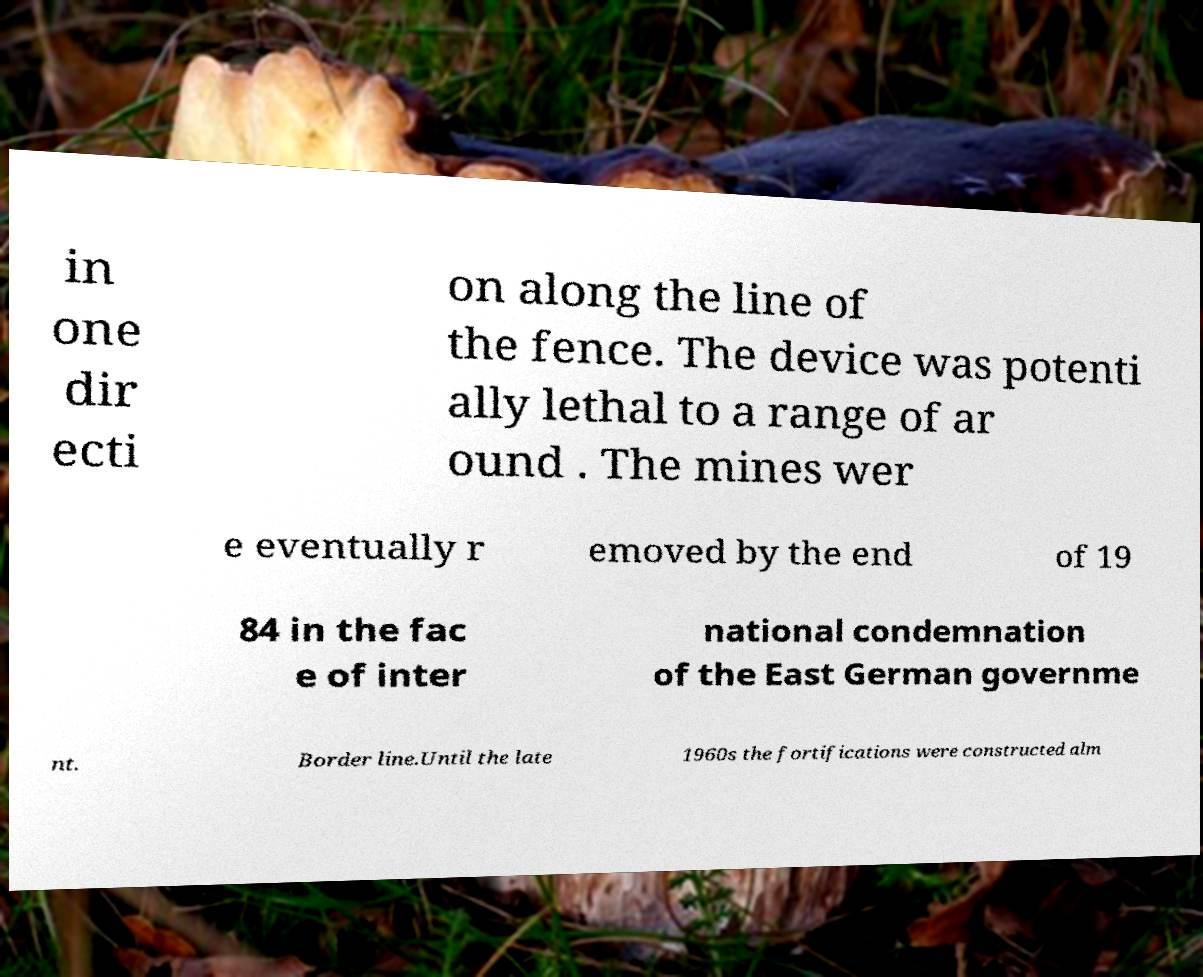Please read and relay the text visible in this image. What does it say? in one dir ecti on along the line of the fence. The device was potenti ally lethal to a range of ar ound . The mines wer e eventually r emoved by the end of 19 84 in the fac e of inter national condemnation of the East German governme nt. Border line.Until the late 1960s the fortifications were constructed alm 